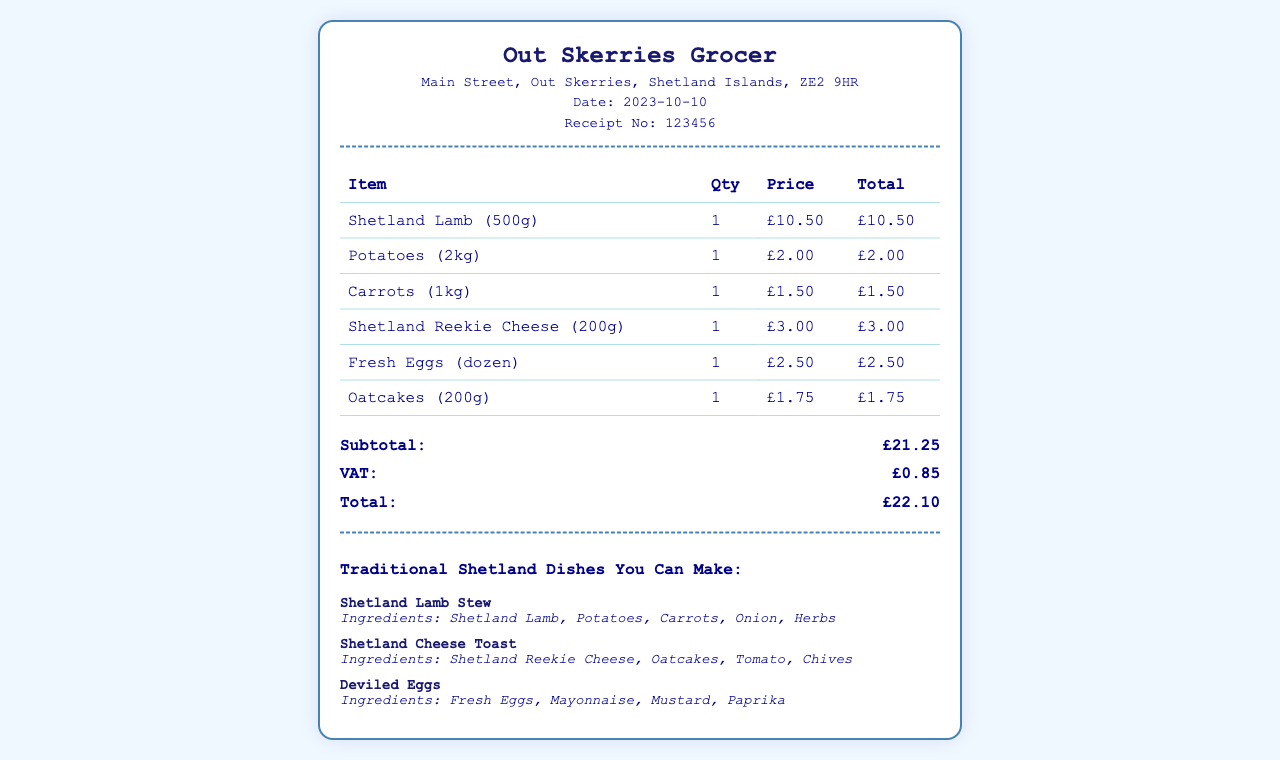What is the store name? The store name is listed at the top of the receipt, which identifies the grocery store where the purchase was made.
Answer: Out Skerries Grocer What is the date of the receipt? The date is found near the top, indicating when the purchase occurred.
Answer: 2023-10-10 What is the total amount paid? The total amount is summed from the subtotal and VAT sections of the receipt.
Answer: £22.10 How much is the VAT? The VAT amount is specified in a separate section of the receipt for clarity.
Answer: £0.85 What is one ingredient for Shetland Lamb Stew? The dish list under traditional Shetland dishes details the ingredients for recipes that can be made.
Answer: Shetland Lamb How many eggs are in a dozen? This is a basic fact regarding the quantity of items in the fresh eggs purchase.
Answer: 12 What is the price of Shetland Reekie Cheese? The price is shown in the table under the price column for each item purchased.
Answer: £3.00 Which dish contains oatcakes? The dish ingredients are listed, indicating which dish uses oatcakes as an ingredient.
Answer: Shetland Cheese Toast What quantity of potatoes was purchased? The quantity column indicates how much of each item was purchased.
Answer: 1 